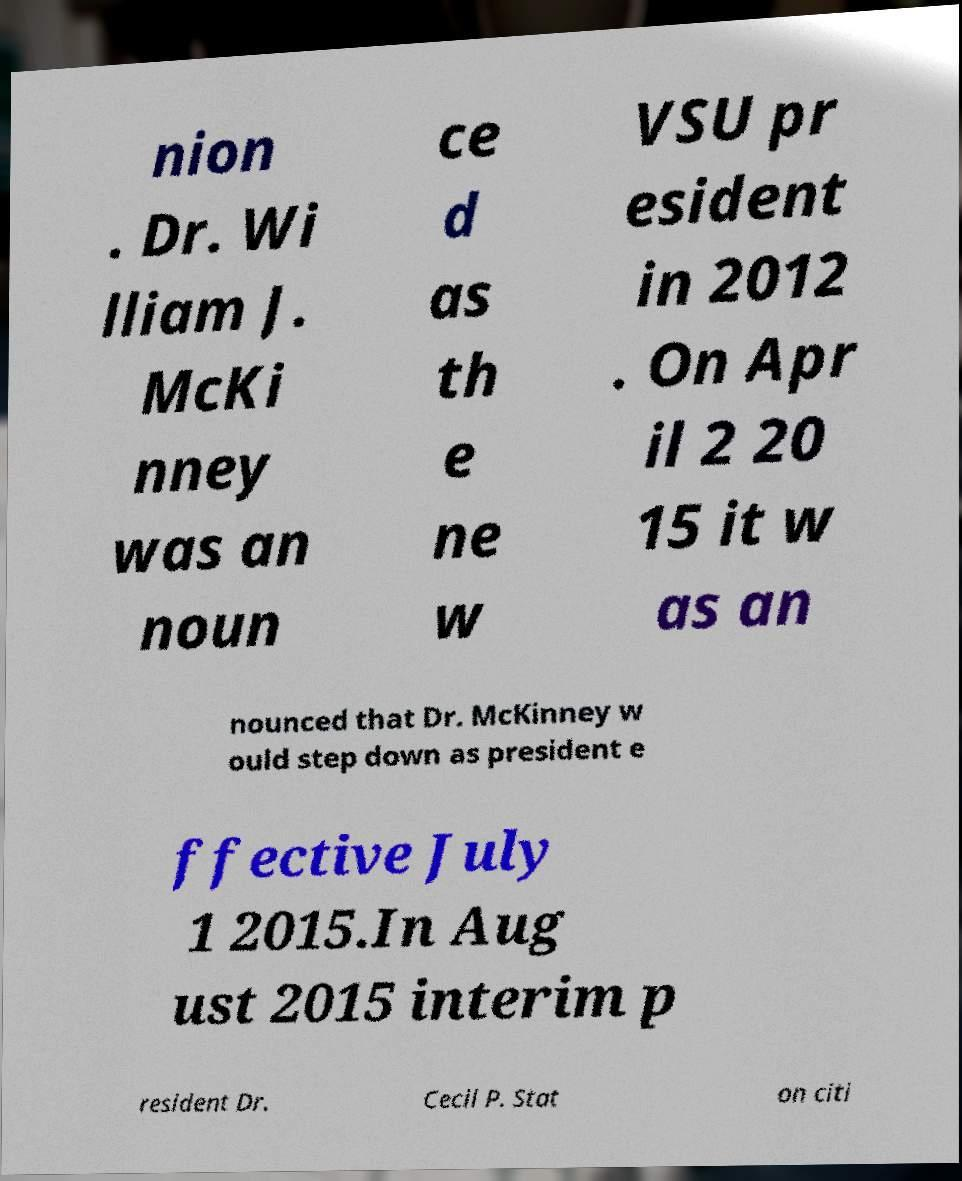Could you extract and type out the text from this image? nion . Dr. Wi lliam J. McKi nney was an noun ce d as th e ne w VSU pr esident in 2012 . On Apr il 2 20 15 it w as an nounced that Dr. McKinney w ould step down as president e ffective July 1 2015.In Aug ust 2015 interim p resident Dr. Cecil P. Stat on citi 